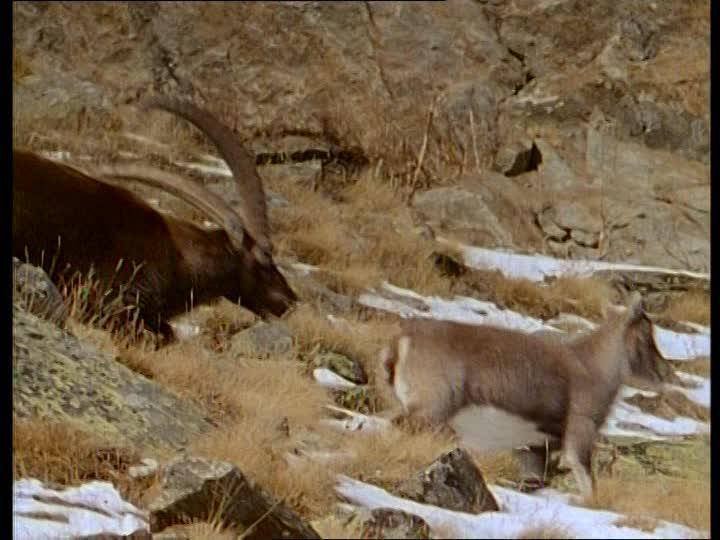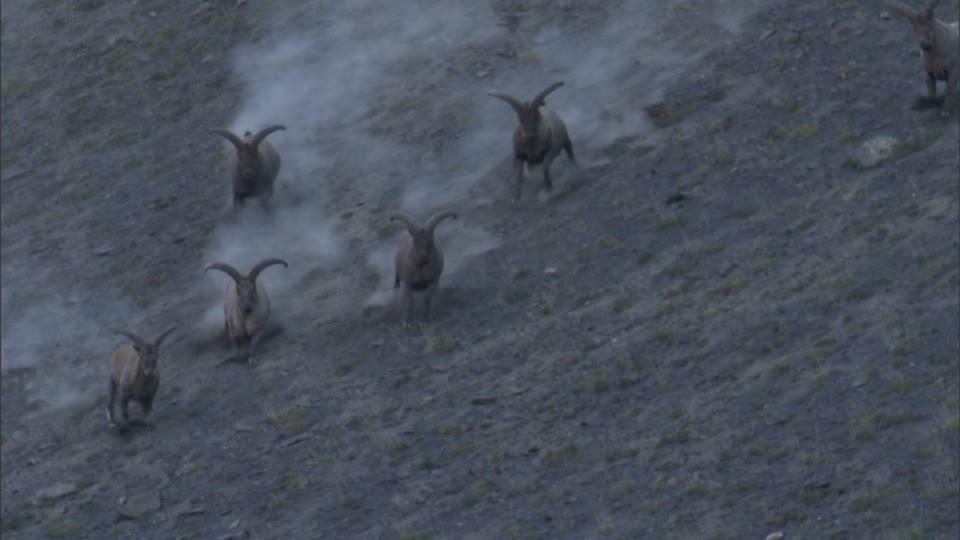The first image is the image on the left, the second image is the image on the right. Evaluate the accuracy of this statement regarding the images: "There is snow on the ground in the right image.". Is it true? Answer yes or no. No. 